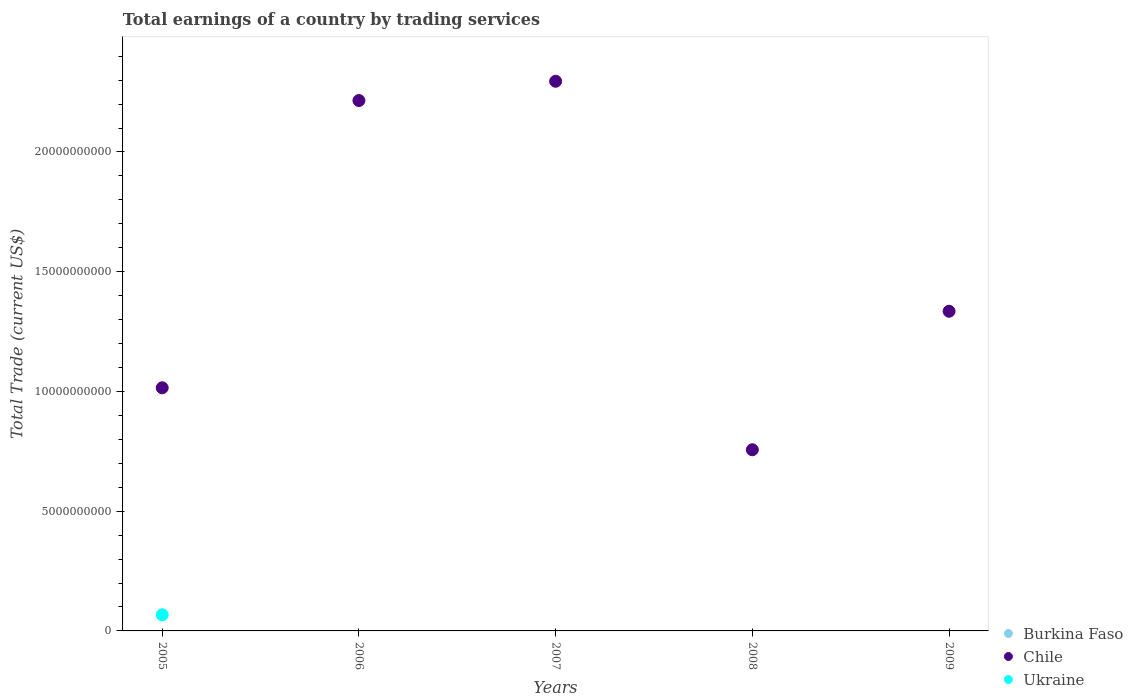How many different coloured dotlines are there?
Keep it short and to the point. 2. Is the number of dotlines equal to the number of legend labels?
Your answer should be very brief. No. What is the total earnings in Ukraine in 2007?
Offer a terse response. 0. Across all years, what is the maximum total earnings in Ukraine?
Keep it short and to the point. 6.74e+08. What is the total total earnings in Ukraine in the graph?
Give a very brief answer. 6.74e+08. What is the difference between the total earnings in Chile in 2006 and that in 2009?
Your response must be concise. 8.80e+09. What is the difference between the total earnings in Chile in 2009 and the total earnings in Burkina Faso in 2007?
Make the answer very short. 1.33e+1. What is the average total earnings in Chile per year?
Offer a terse response. 1.52e+1. What is the ratio of the total earnings in Chile in 2005 to that in 2008?
Make the answer very short. 1.34. Is the total earnings in Chile in 2007 less than that in 2009?
Your answer should be very brief. No. What is the difference between the highest and the second highest total earnings in Chile?
Keep it short and to the point. 8.05e+08. What is the difference between the highest and the lowest total earnings in Chile?
Give a very brief answer. 1.54e+1. Is the total earnings in Chile strictly greater than the total earnings in Burkina Faso over the years?
Provide a short and direct response. Yes. Is the total earnings in Ukraine strictly less than the total earnings in Chile over the years?
Offer a terse response. Yes. How many dotlines are there?
Give a very brief answer. 2. How many years are there in the graph?
Keep it short and to the point. 5. What is the difference between two consecutive major ticks on the Y-axis?
Keep it short and to the point. 5.00e+09. Are the values on the major ticks of Y-axis written in scientific E-notation?
Give a very brief answer. No. Where does the legend appear in the graph?
Offer a terse response. Bottom right. How many legend labels are there?
Your response must be concise. 3. What is the title of the graph?
Offer a very short reply. Total earnings of a country by trading services. What is the label or title of the Y-axis?
Ensure brevity in your answer.  Total Trade (current US$). What is the Total Trade (current US$) of Chile in 2005?
Give a very brief answer. 1.02e+1. What is the Total Trade (current US$) of Ukraine in 2005?
Ensure brevity in your answer.  6.74e+08. What is the Total Trade (current US$) in Chile in 2006?
Provide a succinct answer. 2.21e+1. What is the Total Trade (current US$) in Ukraine in 2006?
Provide a short and direct response. 0. What is the Total Trade (current US$) in Burkina Faso in 2007?
Your response must be concise. 0. What is the Total Trade (current US$) of Chile in 2007?
Your answer should be very brief. 2.30e+1. What is the Total Trade (current US$) in Ukraine in 2007?
Provide a short and direct response. 0. What is the Total Trade (current US$) in Burkina Faso in 2008?
Make the answer very short. 0. What is the Total Trade (current US$) in Chile in 2008?
Offer a very short reply. 7.56e+09. What is the Total Trade (current US$) in Burkina Faso in 2009?
Your response must be concise. 0. What is the Total Trade (current US$) of Chile in 2009?
Provide a succinct answer. 1.33e+1. What is the Total Trade (current US$) in Ukraine in 2009?
Keep it short and to the point. 0. Across all years, what is the maximum Total Trade (current US$) in Chile?
Offer a very short reply. 2.30e+1. Across all years, what is the maximum Total Trade (current US$) of Ukraine?
Provide a succinct answer. 6.74e+08. Across all years, what is the minimum Total Trade (current US$) of Chile?
Offer a very short reply. 7.56e+09. What is the total Total Trade (current US$) of Chile in the graph?
Your answer should be very brief. 7.62e+1. What is the total Total Trade (current US$) of Ukraine in the graph?
Your answer should be very brief. 6.74e+08. What is the difference between the Total Trade (current US$) in Chile in 2005 and that in 2006?
Give a very brief answer. -1.20e+1. What is the difference between the Total Trade (current US$) in Chile in 2005 and that in 2007?
Offer a very short reply. -1.28e+1. What is the difference between the Total Trade (current US$) in Chile in 2005 and that in 2008?
Offer a very short reply. 2.59e+09. What is the difference between the Total Trade (current US$) of Chile in 2005 and that in 2009?
Your answer should be very brief. -3.20e+09. What is the difference between the Total Trade (current US$) of Chile in 2006 and that in 2007?
Your answer should be very brief. -8.05e+08. What is the difference between the Total Trade (current US$) in Chile in 2006 and that in 2008?
Ensure brevity in your answer.  1.46e+1. What is the difference between the Total Trade (current US$) of Chile in 2006 and that in 2009?
Make the answer very short. 8.80e+09. What is the difference between the Total Trade (current US$) of Chile in 2007 and that in 2008?
Your answer should be very brief. 1.54e+1. What is the difference between the Total Trade (current US$) of Chile in 2007 and that in 2009?
Your response must be concise. 9.60e+09. What is the difference between the Total Trade (current US$) in Chile in 2008 and that in 2009?
Give a very brief answer. -5.78e+09. What is the average Total Trade (current US$) in Chile per year?
Your response must be concise. 1.52e+1. What is the average Total Trade (current US$) in Ukraine per year?
Keep it short and to the point. 1.35e+08. In the year 2005, what is the difference between the Total Trade (current US$) in Chile and Total Trade (current US$) in Ukraine?
Your answer should be compact. 9.48e+09. What is the ratio of the Total Trade (current US$) of Chile in 2005 to that in 2006?
Ensure brevity in your answer.  0.46. What is the ratio of the Total Trade (current US$) in Chile in 2005 to that in 2007?
Your response must be concise. 0.44. What is the ratio of the Total Trade (current US$) of Chile in 2005 to that in 2008?
Offer a very short reply. 1.34. What is the ratio of the Total Trade (current US$) in Chile in 2005 to that in 2009?
Provide a succinct answer. 0.76. What is the ratio of the Total Trade (current US$) of Chile in 2006 to that in 2007?
Your answer should be very brief. 0.96. What is the ratio of the Total Trade (current US$) in Chile in 2006 to that in 2008?
Provide a short and direct response. 2.93. What is the ratio of the Total Trade (current US$) in Chile in 2006 to that in 2009?
Your answer should be compact. 1.66. What is the ratio of the Total Trade (current US$) in Chile in 2007 to that in 2008?
Make the answer very short. 3.03. What is the ratio of the Total Trade (current US$) in Chile in 2007 to that in 2009?
Ensure brevity in your answer.  1.72. What is the ratio of the Total Trade (current US$) in Chile in 2008 to that in 2009?
Ensure brevity in your answer.  0.57. What is the difference between the highest and the second highest Total Trade (current US$) of Chile?
Make the answer very short. 8.05e+08. What is the difference between the highest and the lowest Total Trade (current US$) of Chile?
Ensure brevity in your answer.  1.54e+1. What is the difference between the highest and the lowest Total Trade (current US$) of Ukraine?
Your answer should be very brief. 6.74e+08. 